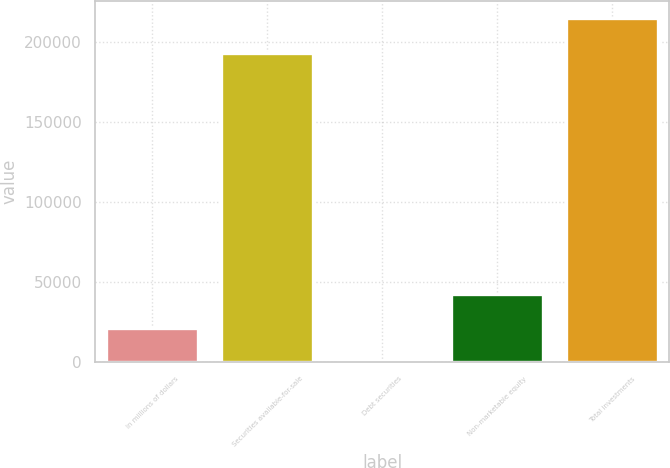Convert chart to OTSL. <chart><loc_0><loc_0><loc_500><loc_500><bar_chart><fcel>In millions of dollars<fcel>Securities available-for-sale<fcel>Debt securities<fcel>Non-marketable equity<fcel>Total investments<nl><fcel>21501.7<fcel>193113<fcel>1<fcel>43002.4<fcel>215008<nl></chart> 